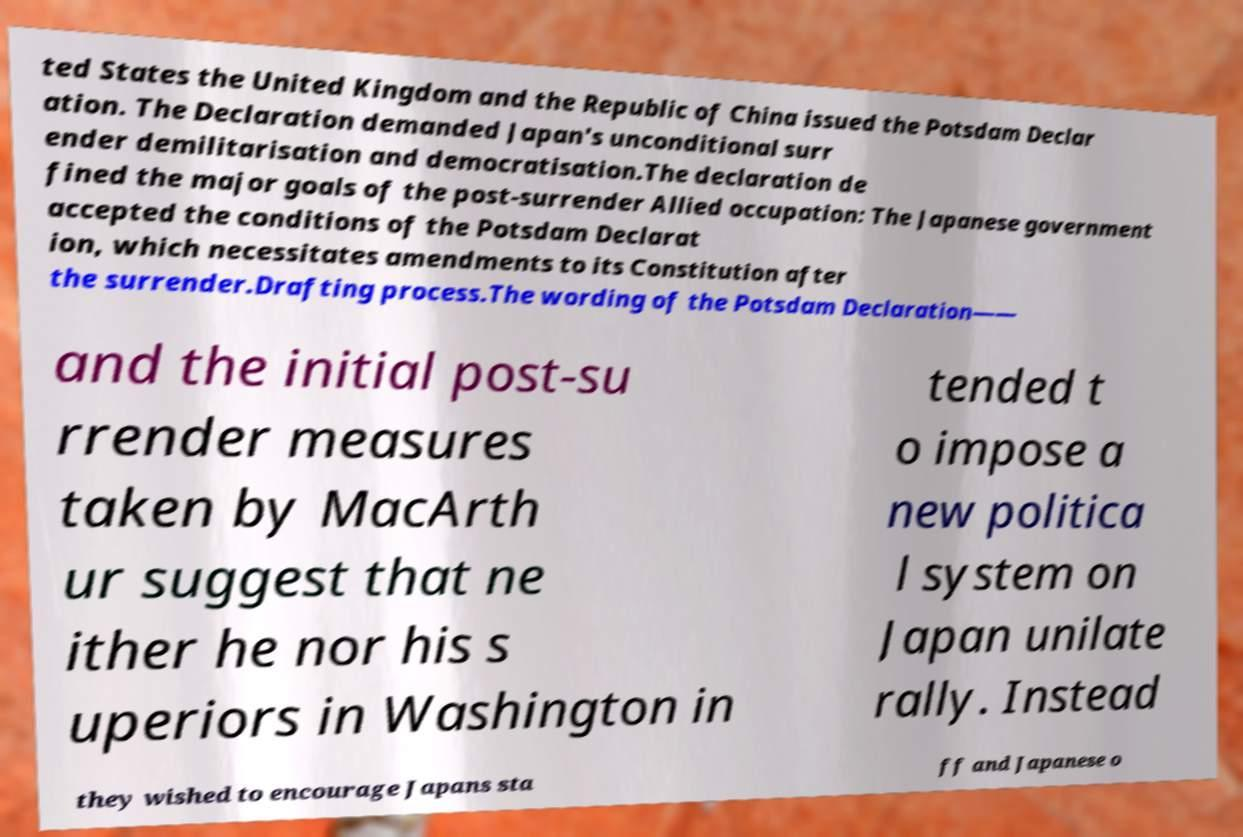For documentation purposes, I need the text within this image transcribed. Could you provide that? ted States the United Kingdom and the Republic of China issued the Potsdam Declar ation. The Declaration demanded Japan's unconditional surr ender demilitarisation and democratisation.The declaration de fined the major goals of the post-surrender Allied occupation: The Japanese government accepted the conditions of the Potsdam Declarat ion, which necessitates amendments to its Constitution after the surrender.Drafting process.The wording of the Potsdam Declaration—— and the initial post-su rrender measures taken by MacArth ur suggest that ne ither he nor his s uperiors in Washington in tended t o impose a new politica l system on Japan unilate rally. Instead they wished to encourage Japans sta ff and Japanese o 